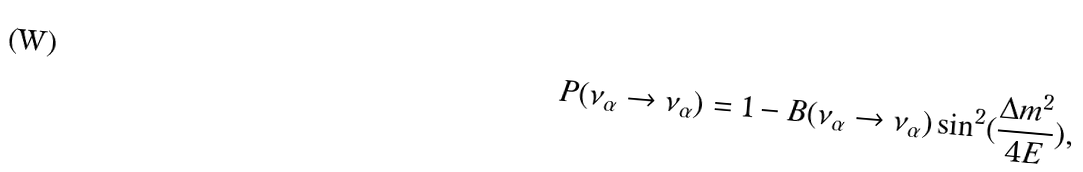Convert formula to latex. <formula><loc_0><loc_0><loc_500><loc_500>P ( \nu _ { \alpha } \rightarrow \nu _ { \alpha } ) = 1 - B ( \nu _ { \alpha } \rightarrow \nu _ { \alpha } ) \sin ^ { 2 } ( \frac { \Delta m ^ { 2 } } { 4 E } ) ,</formula> 